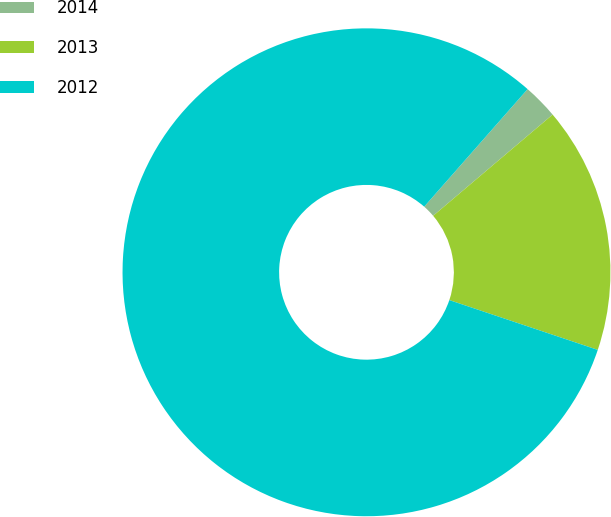Convert chart. <chart><loc_0><loc_0><loc_500><loc_500><pie_chart><fcel>2014<fcel>2013<fcel>2012<nl><fcel>2.33%<fcel>16.34%<fcel>81.33%<nl></chart> 